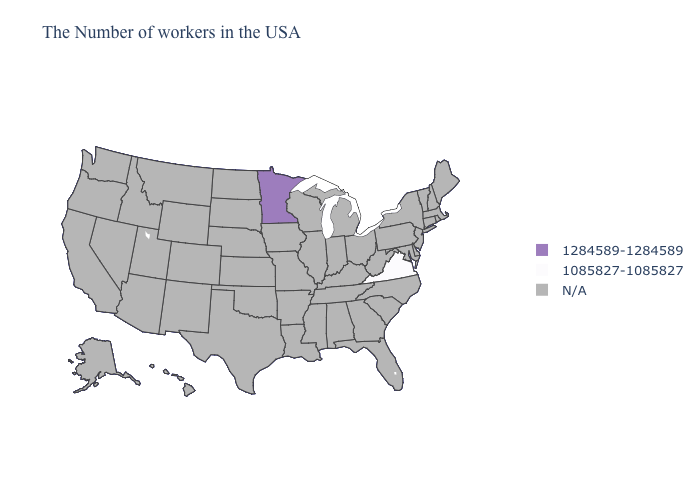What is the value of Kansas?
Short answer required. N/A. Which states have the lowest value in the USA?
Short answer required. Virginia. What is the value of Alabama?
Short answer required. N/A. Name the states that have a value in the range 1284589-1284589?
Answer briefly. Minnesota. Which states have the lowest value in the USA?
Be succinct. Virginia. What is the value of Kentucky?
Be succinct. N/A. Is the legend a continuous bar?
Quick response, please. No. Does the map have missing data?
Quick response, please. Yes. Name the states that have a value in the range 1284589-1284589?
Concise answer only. Minnesota. What is the value of South Carolina?
Be succinct. N/A. Among the states that border West Virginia , which have the highest value?
Write a very short answer. Virginia. How many symbols are there in the legend?
Write a very short answer. 3. 